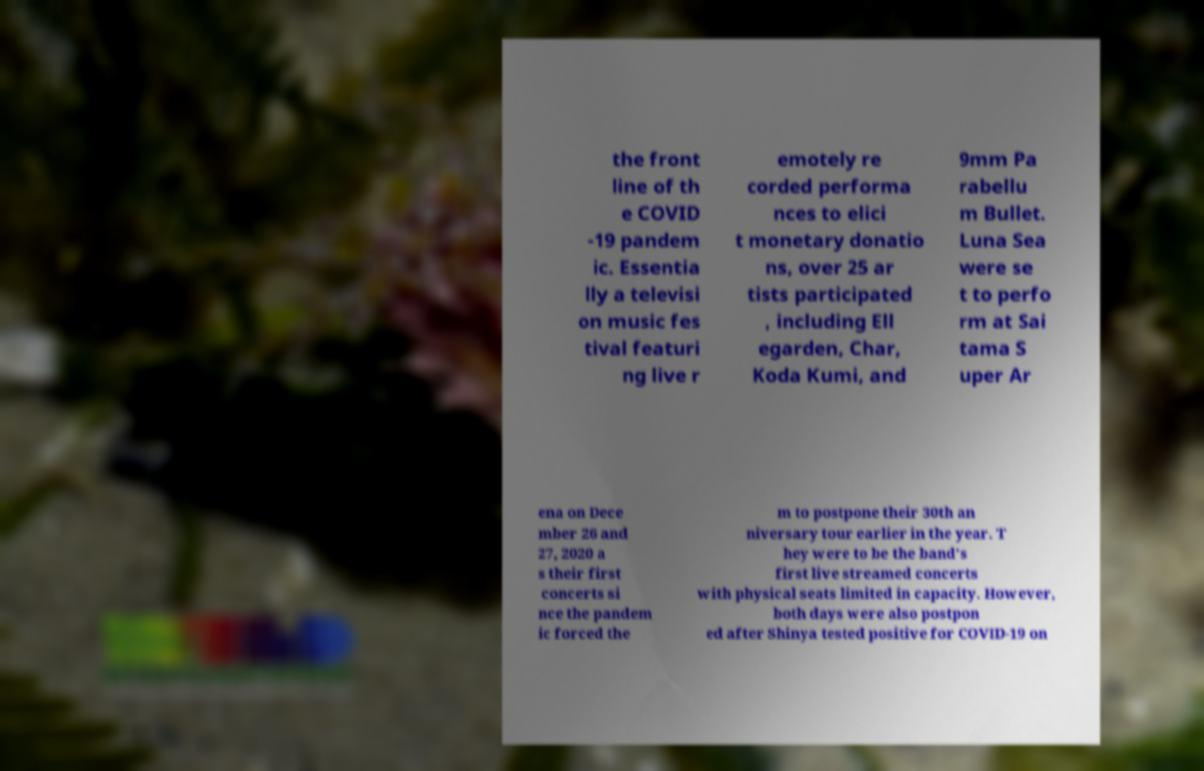Please identify and transcribe the text found in this image. the front line of th e COVID -19 pandem ic. Essentia lly a televisi on music fes tival featuri ng live r emotely re corded performa nces to elici t monetary donatio ns, over 25 ar tists participated , including Ell egarden, Char, Koda Kumi, and 9mm Pa rabellu m Bullet. Luna Sea were se t to perfo rm at Sai tama S uper Ar ena on Dece mber 26 and 27, 2020 a s their first concerts si nce the pandem ic forced the m to postpone their 30th an niversary tour earlier in the year. T hey were to be the band's first live streamed concerts with physical seats limited in capacity. However, both days were also postpon ed after Shinya tested positive for COVID-19 on 